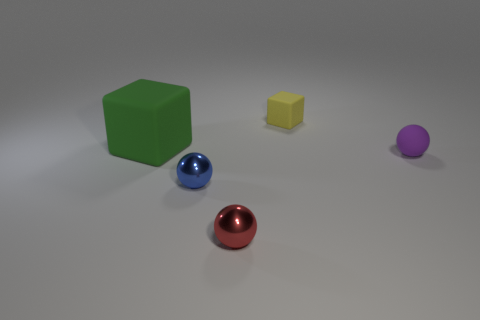Are there any other things that have the same material as the small block?
Offer a terse response. Yes. Is there anything else that is the same size as the green object?
Your response must be concise. No. Are there any small metal spheres?
Give a very brief answer. Yes. What number of large things are either yellow matte cylinders or blue metallic spheres?
Provide a short and direct response. 0. Is there anything else that has the same color as the tiny rubber cube?
Provide a succinct answer. No. There is a yellow thing that is made of the same material as the big green thing; what shape is it?
Ensure brevity in your answer.  Cube. There is a matte block to the left of the yellow matte block; what size is it?
Provide a succinct answer. Large. What shape is the purple matte thing?
Ensure brevity in your answer.  Sphere. Is the size of the purple matte object in front of the large green cube the same as the cube right of the green block?
Your answer should be very brief. Yes. There is a matte cube right of the sphere that is in front of the tiny thing that is left of the red metallic ball; what is its size?
Make the answer very short. Small. 